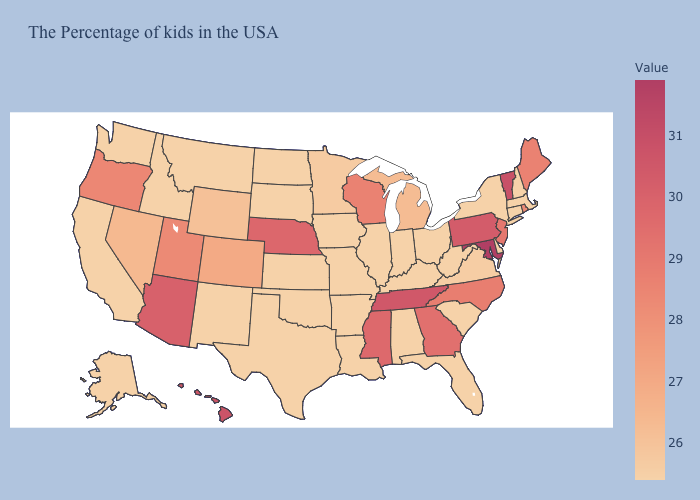Which states have the lowest value in the USA?
Keep it brief. Massachusetts, New Hampshire, Connecticut, New York, Delaware, South Carolina, West Virginia, Ohio, Florida, Kentucky, Indiana, Alabama, Illinois, Louisiana, Missouri, Arkansas, Iowa, Kansas, Oklahoma, Texas, South Dakota, North Dakota, New Mexico, Montana, Idaho, California, Washington, Alaska. Does Indiana have the highest value in the USA?
Be succinct. No. Which states have the lowest value in the South?
Short answer required. Delaware, South Carolina, West Virginia, Florida, Kentucky, Alabama, Louisiana, Arkansas, Oklahoma, Texas. Which states hav the highest value in the MidWest?
Answer briefly. Nebraska. Among the states that border New Hampshire , does Vermont have the highest value?
Be succinct. Yes. 